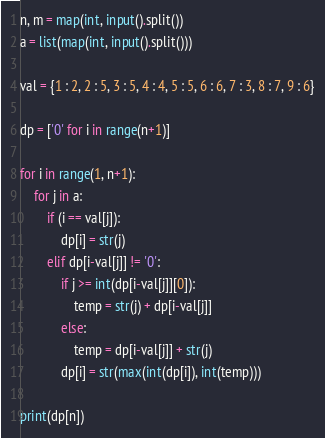Convert code to text. <code><loc_0><loc_0><loc_500><loc_500><_Python_>n, m = map(int, input().split())
a = list(map(int, input().split()))

val = {1 : 2, 2 : 5, 3 : 5, 4 : 4, 5 : 5, 6 : 6, 7 : 3, 8 : 7, 9 : 6}

dp = ['0' for i in range(n+1)]

for i in range(1, n+1):
	for j in a:
		if (i == val[j]):
			dp[i] = str(j)
		elif dp[i-val[j]] != '0':
			if j >= int(dp[i-val[j]][0]):
				temp = str(j) + dp[i-val[j]]
			else:
				temp = dp[i-val[j]] + str(j)
			dp[i] = str(max(int(dp[i]), int(temp)))

print(dp[n])</code> 